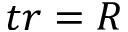Convert formula to latex. <formula><loc_0><loc_0><loc_500><loc_500>t r = R</formula> 